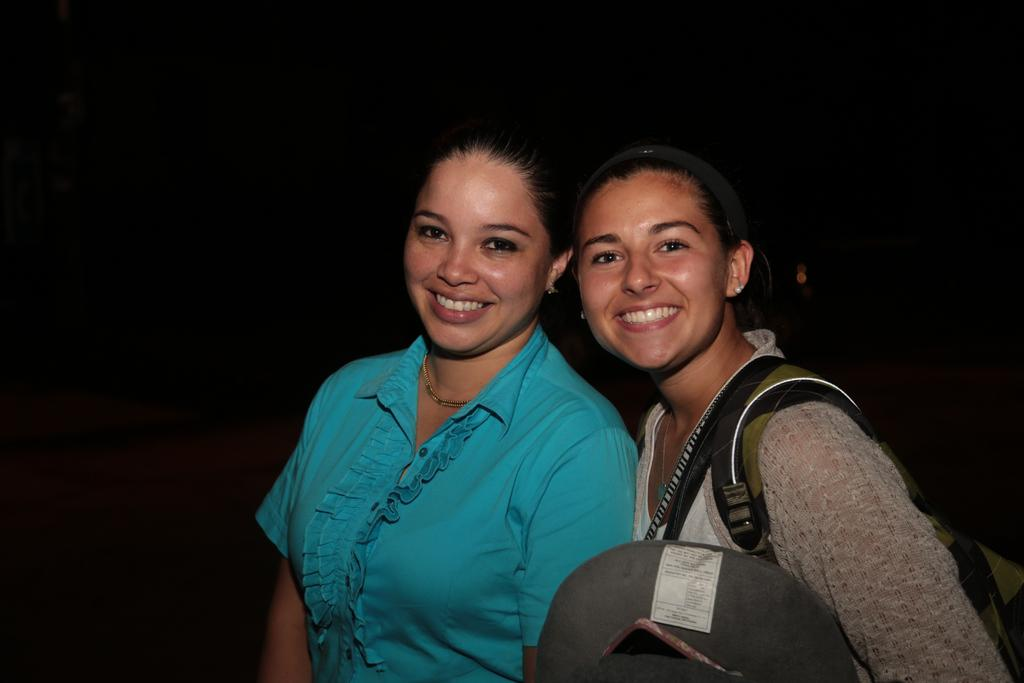How many women are in the image? There are two women in the image. What are the women doing in the image? Both women are standing and smiling. Can you describe the clothing of the woman on the right? The woman on the right is wearing bags. What is the color of the background in the image? The background of the image is dark. What is the name of the woman on the left? The provided facts do not include any names, so we cannot determine the name of the woman on the left. Can you smell the scent of the socks in the image? There are no socks present in the image, so we cannot smell any scent. 